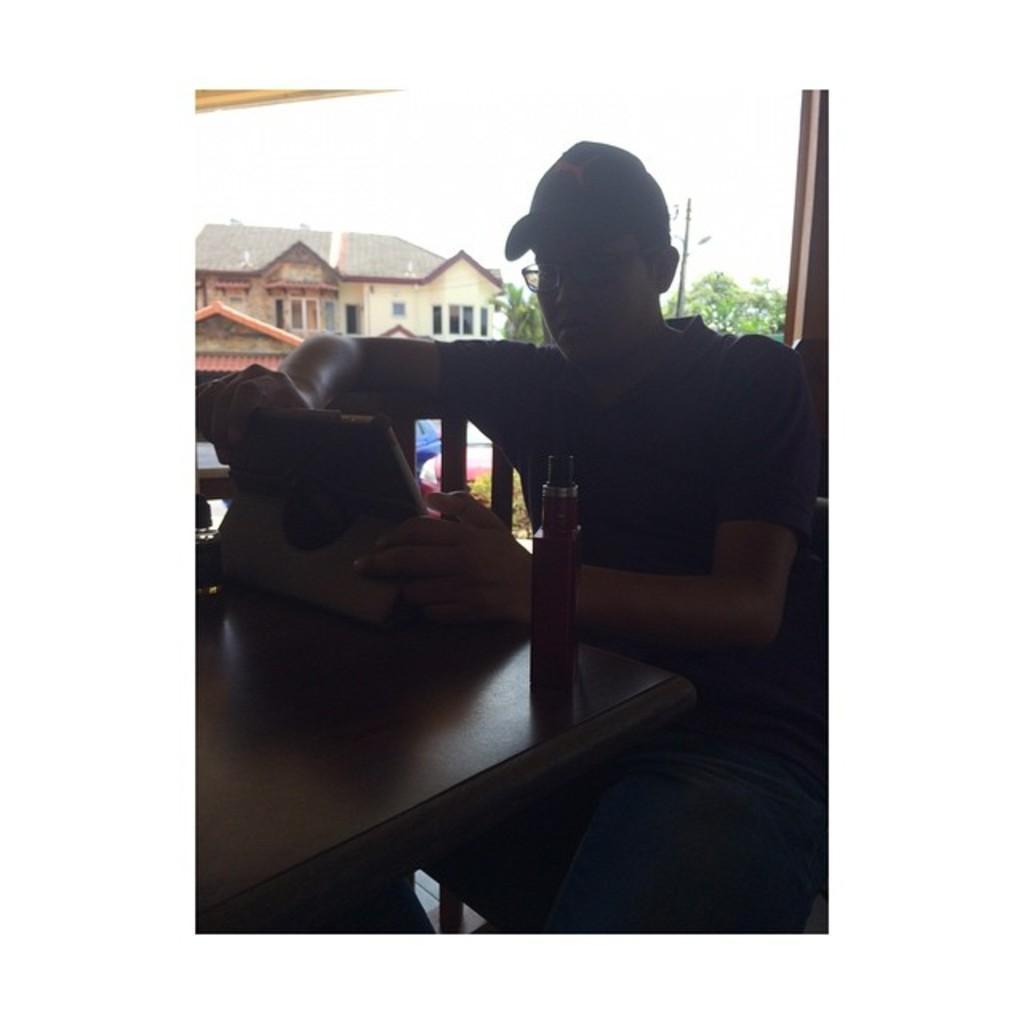How would you summarize this image in a sentence or two? This image consists of a man sitting in a chair and holding a device. In front of him, there is a table. In the background, there is a window through which we can see a building and trees. 